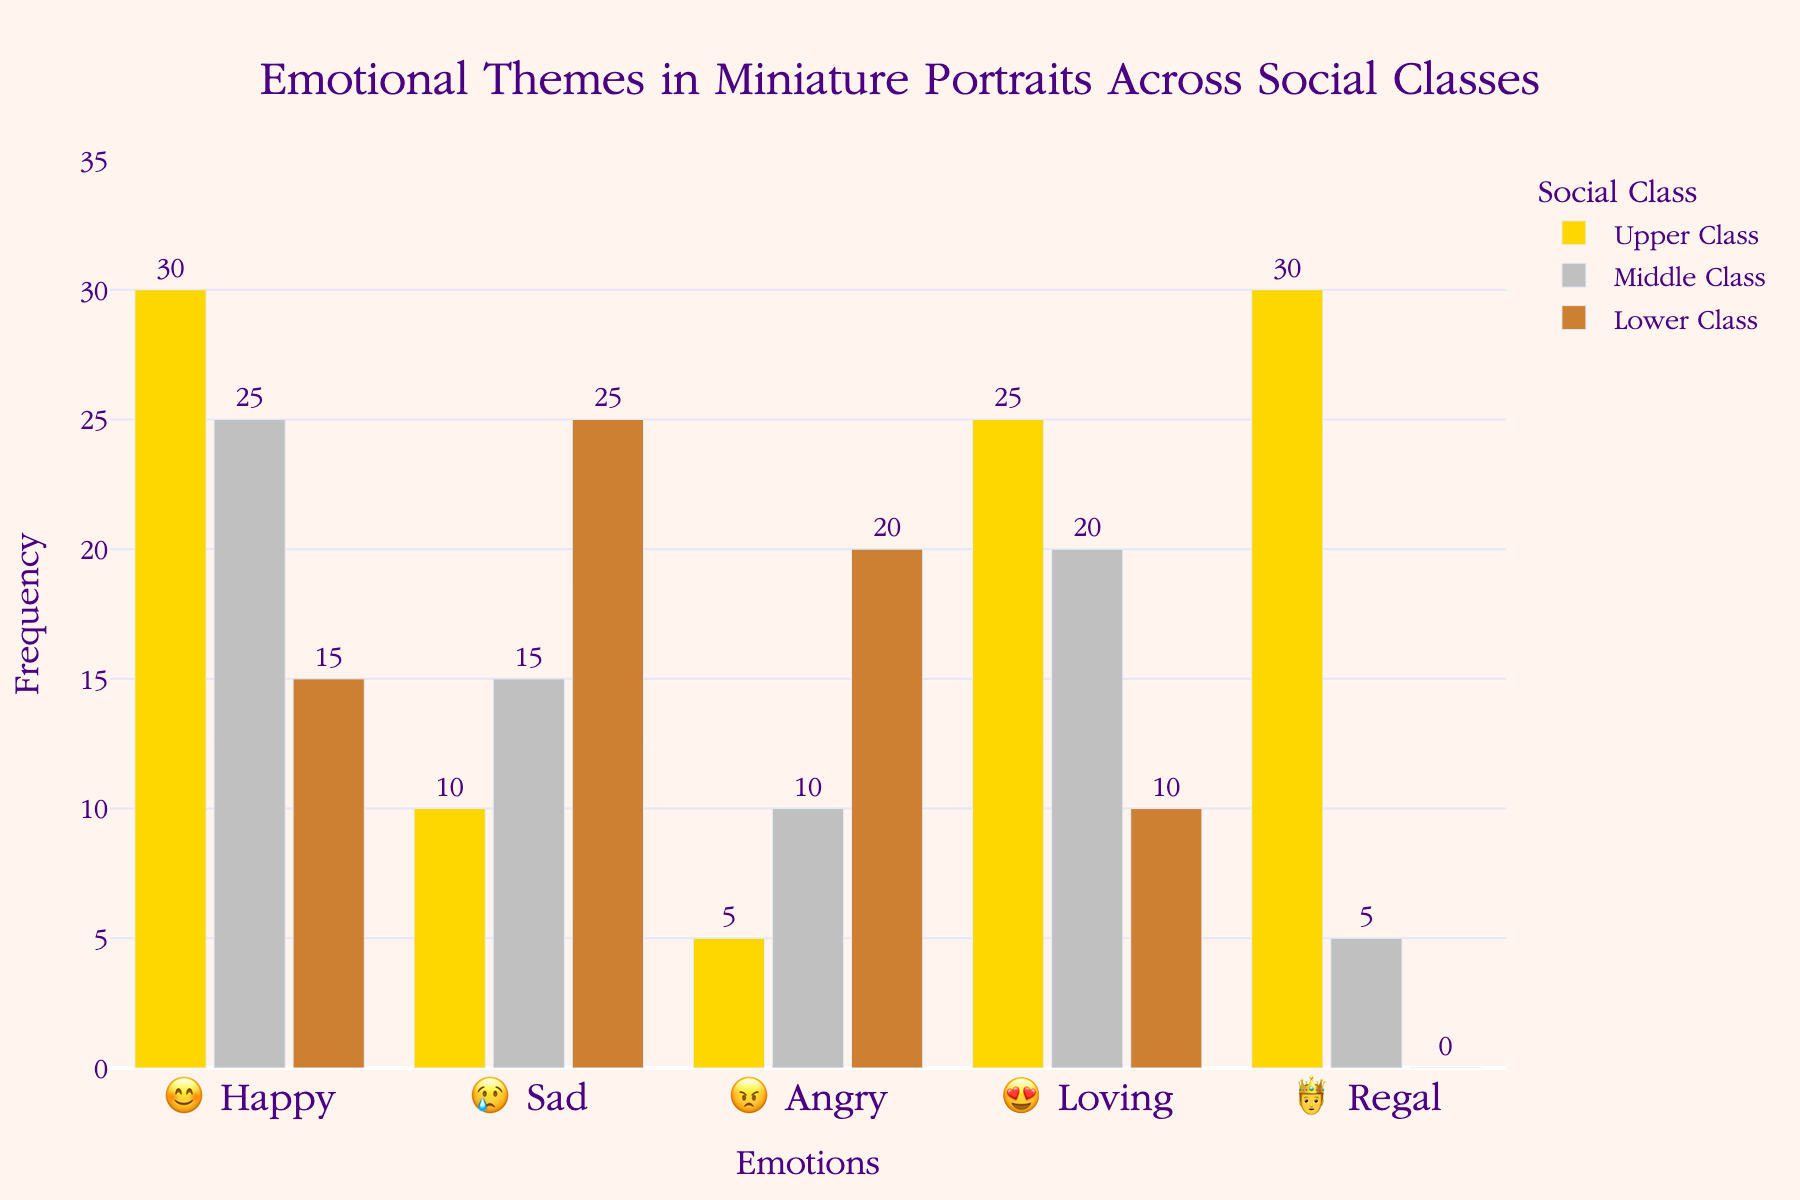What's the title of the chart? At the top center of the chart, the title reads "Emotional Themes in Miniature Portraits Across Social Classes".
Answer: Emotional Themes in Miniature Portraits Across Social Classes Which social class has the highest frequency for the "😍 Loving" emotion? By looking at the bars for the "😍 Loving" emotion, the tallest bar is for the Upper Class.
Answer: Upper Class What is the total frequency of the "😊 Happy" emotion across all social classes? Summing up the frequencies for "😊 Happy" in Upper Class (30), Middle Class (25), and Lower Class (15) gives 30 + 25 + 15 = 70.
Answer: 70 Compare the frequency of the "😢 Sad" emotion in the Lower Class and Middle Class. Which is higher? The "😢 Sad" emotion frequency is 25 for the Lower Class and 15 for the Middle Class. Since 25 > 15, the Lower Class is higher.
Answer: Lower Class What is the difference in frequency for the "🤴 Regal" emotion between the Upper Class and Middle Class? Subtracting the Middle Class frequency (5) from the Upper Class frequency (30) for "🤴 Regal" gives 30 - 5 = 25.
Answer: 25 What color represents the Middle Class in the chart? The legend indicates the bar for the Middle Class is colored in silver/gray.
Answer: silver/gray What's the average frequency of emotions depicted in the Lower Class? Summing up all the frequencies for the Lower Class (15, 25, 20, 10, 0) gives 70. Dividing this by the number of emotions (5) gives 70 / 5 = 14.
Answer: 14 Which emotion has zero representation in the Lower Class? Looking at the bars, the "🤴 Regal" emotion has a frequency of 0 for the Lower Class.
Answer: 🤴 Regal Which emotional theme is depicted mostly by the Upper Class? The tallest bar in the Upper Class category corresponds to the "😊 Happy" and "🤴 Regal" emotions, both at 30.
Answer: 😊 Happy and 🤴 Regal 